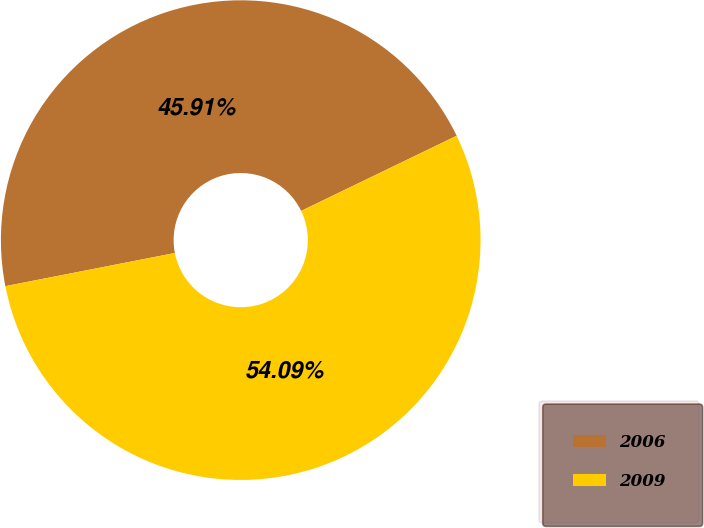Convert chart. <chart><loc_0><loc_0><loc_500><loc_500><pie_chart><fcel>2006<fcel>2009<nl><fcel>45.91%<fcel>54.09%<nl></chart> 